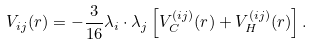<formula> <loc_0><loc_0><loc_500><loc_500>V _ { i j } ( r ) = - \frac { 3 } { 1 6 } { \lambda } _ { i } \cdot { \lambda } _ { j } \left [ V _ { C } ^ { ( i j ) } ( r ) + V _ { H } ^ { ( i j ) } ( r ) \right ] .</formula> 